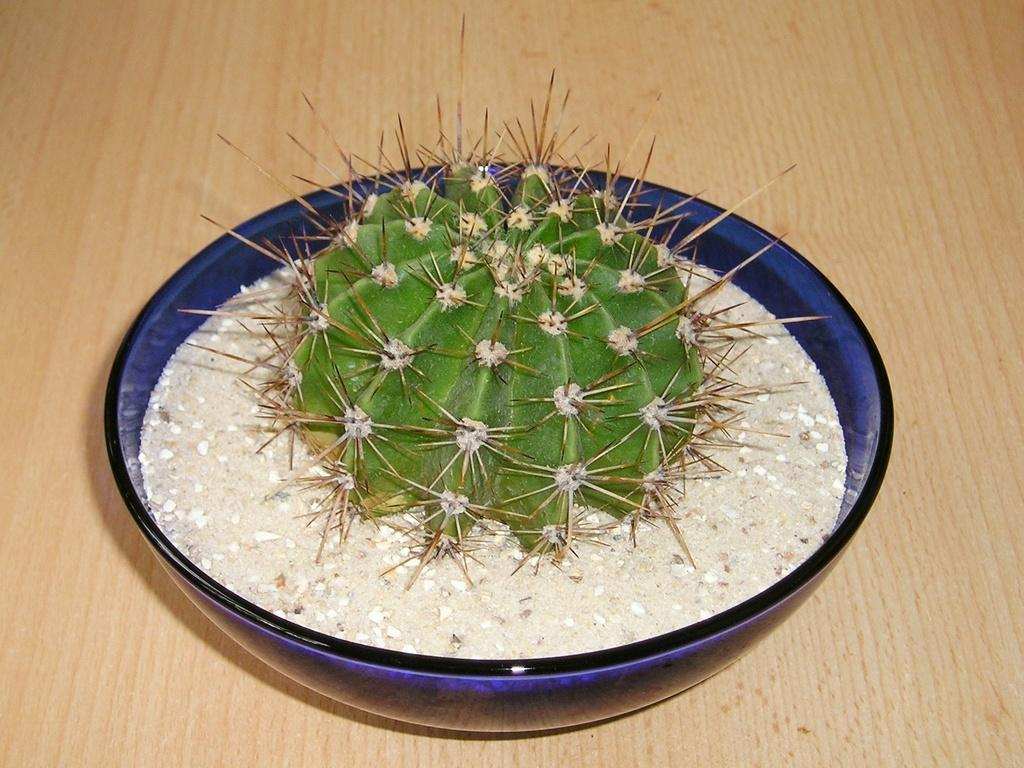What is the color of the surface in the image? The surface in the image is cream-colored. What is placed on the surface? There is a blue-colored bowl on the surface. What is inside the bowl? The bowl contains a plant. What colors can be seen on the plant? The plant has green, cream, and brown colors. How does the goldfish in the image draw attention to itself? There is no goldfish present in the image. What type of patch is visible on the plant in the image? There is no patch visible on the plant in the image. 